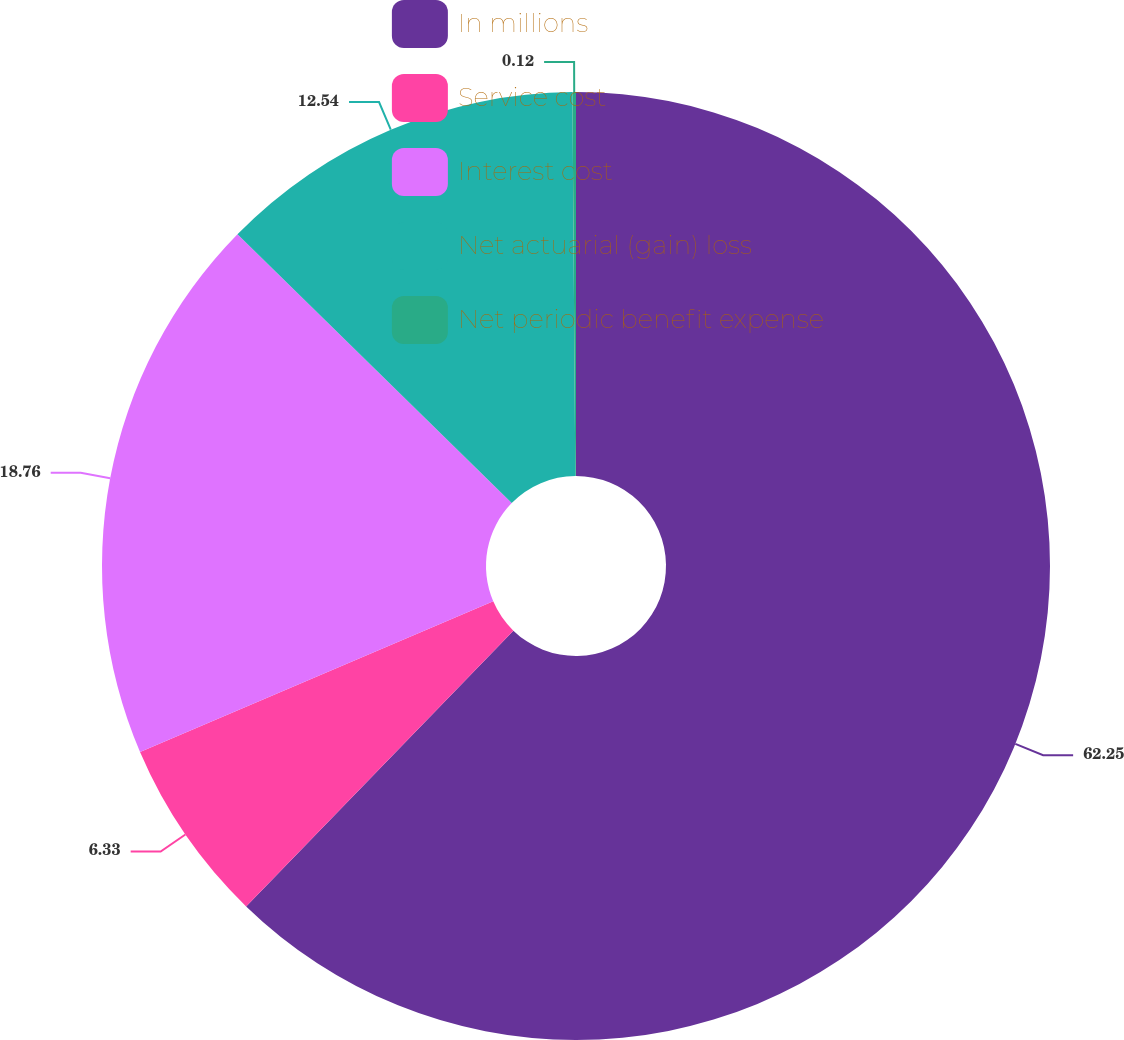<chart> <loc_0><loc_0><loc_500><loc_500><pie_chart><fcel>In millions<fcel>Service cost<fcel>Interest cost<fcel>Net actuarial (gain) loss<fcel>Net periodic benefit expense<nl><fcel>62.25%<fcel>6.33%<fcel>18.76%<fcel>12.54%<fcel>0.12%<nl></chart> 